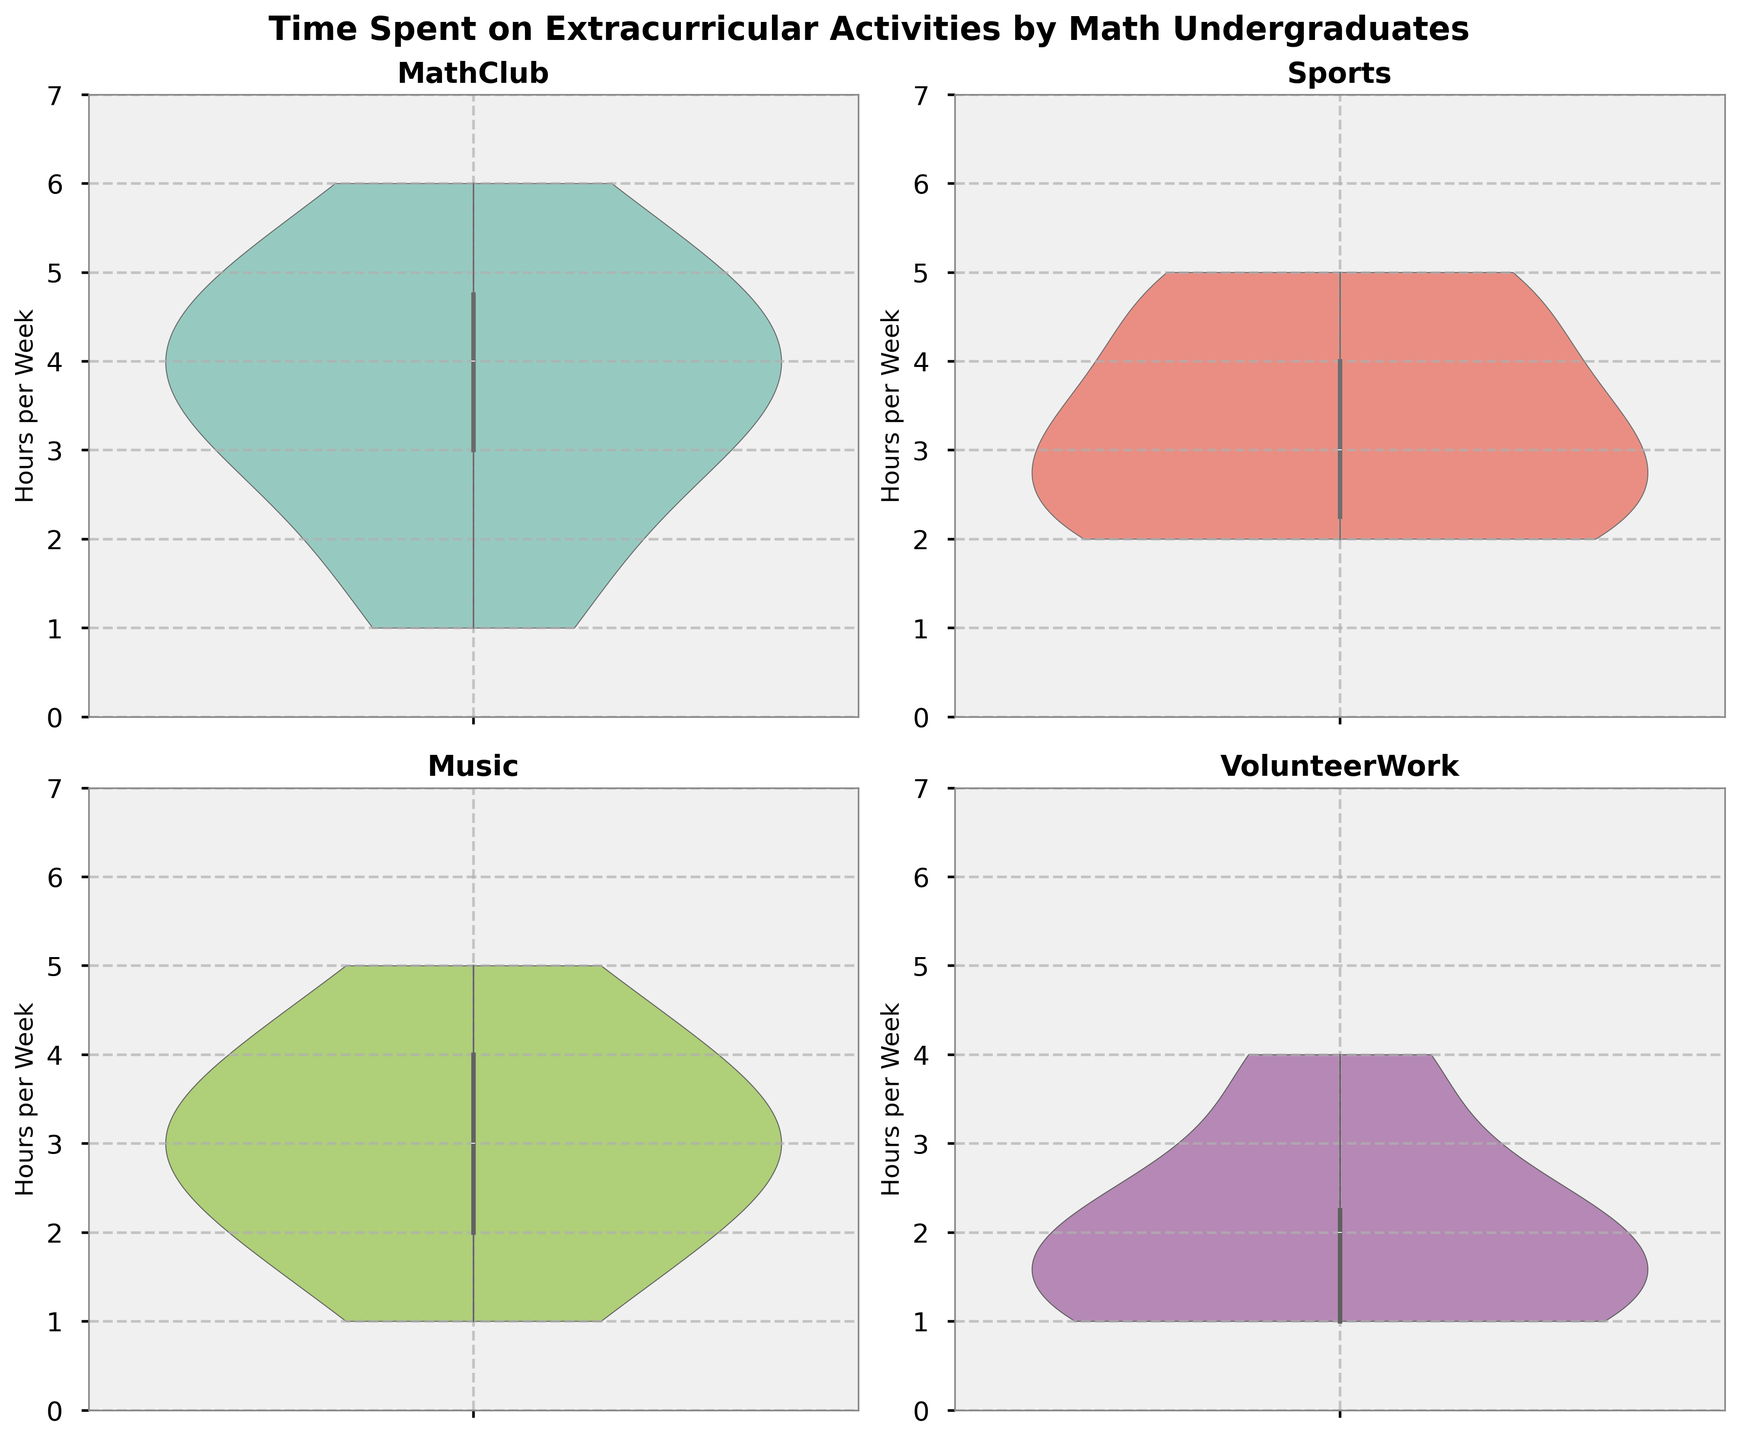What is the title of the figure? The title of the figure is usually located at the top and gives an overall description of what is being represented. In this case, the figure's title is "Time Spent on Extracurricular Activities by Math Undergraduates."
Answer: Time Spent on Extracurricular Activities by Math Undergraduates Which activity has the widest distribution of time spent? To determine the activity with the widest distribution, observe which violin plot appears widest across different hours per week. The activity with the most spread out data points is the one with the widest distribution.
Answer: Sports What is the median time spent per week on Math Club? In a violin plot, the median is typically indicated by a white dot. By inspecting the Math Club subplot, you can identify where this dot is located on the vertical axis.
Answer: 4 hours Which activity shows the highest maximum time spent? To find the activity with the highest maximum time spent, look for the uppermost point in each violin plot. The activity whose plot extends highest on the y-axis has the highest maximum time spent.
Answer: Math Club Compare the average time spent on Volunteer Work and Sports, which one is higher? To compare averages, look at the density and placement of the data points in the violin plots for Volunteer Work and Sports. The average can be inferred by the central concentration of the plot. Observe that Sports has a greater central density around higher values compared to Volunteer Work.
Answer: Sports What is the time range of the most frequent time spent on Music? The most frequent time spent can be seen in the bulging section of the violin plot for Music. By inspecting this region, one can estimate the range of hours per week where students mostly spend their time.
Answer: 2 to 4 hours Are there any activities where students did not spend any time at all (zero hours)? To determine this, check if any violin plots start precisely at the zero-hour mark on the y-axis. If all plots start above zero, it means no activity had zero hours spent.
Answer: No Which activity has the lowest variability in time spent among students? The activity with the lowest variability will have a violin plot that is narrower and more concentrated around a central value. By inspecting the width and spread, you can identify which activity this is.
Answer: Math Club 